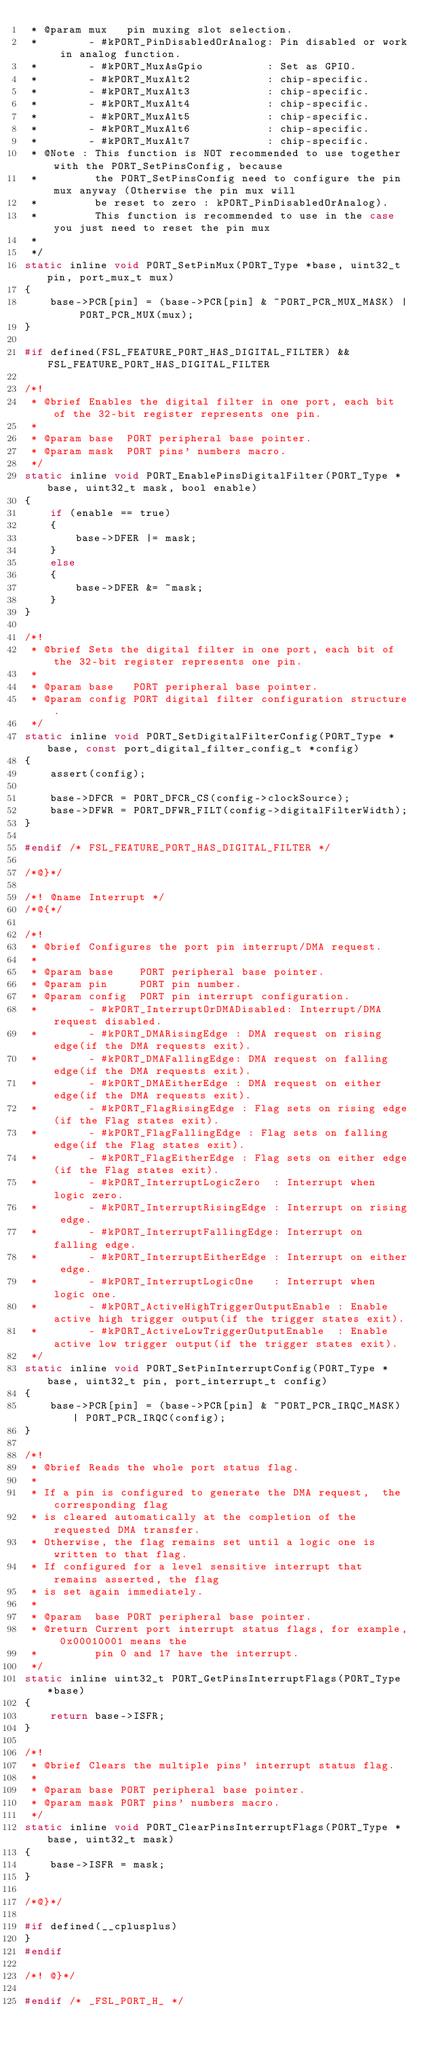<code> <loc_0><loc_0><loc_500><loc_500><_C_> * @param mux   pin muxing slot selection.
 *        - #kPORT_PinDisabledOrAnalog: Pin disabled or work in analog function.
 *        - #kPORT_MuxAsGpio          : Set as GPIO.
 *        - #kPORT_MuxAlt2            : chip-specific.
 *        - #kPORT_MuxAlt3            : chip-specific.
 *        - #kPORT_MuxAlt4            : chip-specific.
 *        - #kPORT_MuxAlt5            : chip-specific.
 *        - #kPORT_MuxAlt6            : chip-specific.
 *        - #kPORT_MuxAlt7            : chip-specific.
 * @Note : This function is NOT recommended to use together with the PORT_SetPinsConfig, because
 *         the PORT_SetPinsConfig need to configure the pin mux anyway (Otherwise the pin mux will
 *         be reset to zero : kPORT_PinDisabledOrAnalog).
 *         This function is recommended to use in the case you just need to reset the pin mux
 *
 */
static inline void PORT_SetPinMux(PORT_Type *base, uint32_t pin, port_mux_t mux)
{
    base->PCR[pin] = (base->PCR[pin] & ~PORT_PCR_MUX_MASK) | PORT_PCR_MUX(mux);
}

#if defined(FSL_FEATURE_PORT_HAS_DIGITAL_FILTER) && FSL_FEATURE_PORT_HAS_DIGITAL_FILTER

/*!
 * @brief Enables the digital filter in one port, each bit of the 32-bit register represents one pin.
 *
 * @param base  PORT peripheral base pointer.
 * @param mask  PORT pins' numbers macro.
 */
static inline void PORT_EnablePinsDigitalFilter(PORT_Type *base, uint32_t mask, bool enable)
{
    if (enable == true)
    {
        base->DFER |= mask;
    }
    else
    {
        base->DFER &= ~mask;
    }
}

/*!
 * @brief Sets the digital filter in one port, each bit of the 32-bit register represents one pin.
 *
 * @param base   PORT peripheral base pointer.
 * @param config PORT digital filter configuration structure.
 */
static inline void PORT_SetDigitalFilterConfig(PORT_Type *base, const port_digital_filter_config_t *config)
{
    assert(config);

    base->DFCR = PORT_DFCR_CS(config->clockSource);
    base->DFWR = PORT_DFWR_FILT(config->digitalFilterWidth);
}

#endif /* FSL_FEATURE_PORT_HAS_DIGITAL_FILTER */

/*@}*/

/*! @name Interrupt */
/*@{*/

/*!
 * @brief Configures the port pin interrupt/DMA request.
 *
 * @param base    PORT peripheral base pointer.
 * @param pin     PORT pin number.
 * @param config  PORT pin interrupt configuration.
 *        - #kPORT_InterruptOrDMADisabled: Interrupt/DMA request disabled.
 *        - #kPORT_DMARisingEdge : DMA request on rising edge(if the DMA requests exit).
 *        - #kPORT_DMAFallingEdge: DMA request on falling edge(if the DMA requests exit).
 *        - #kPORT_DMAEitherEdge : DMA request on either edge(if the DMA requests exit).
 *        - #kPORT_FlagRisingEdge : Flag sets on rising edge(if the Flag states exit).
 *        - #kPORT_FlagFallingEdge : Flag sets on falling edge(if the Flag states exit).
 *        - #kPORT_FlagEitherEdge : Flag sets on either edge(if the Flag states exit).
 *        - #kPORT_InterruptLogicZero  : Interrupt when logic zero.
 *        - #kPORT_InterruptRisingEdge : Interrupt on rising edge.
 *        - #kPORT_InterruptFallingEdge: Interrupt on falling edge.
 *        - #kPORT_InterruptEitherEdge : Interrupt on either edge.
 *        - #kPORT_InterruptLogicOne   : Interrupt when logic one.
 *        - #kPORT_ActiveHighTriggerOutputEnable : Enable active high trigger output(if the trigger states exit).
 *        - #kPORT_ActiveLowTriggerOutputEnable  : Enable active low trigger output(if the trigger states exit).
 */
static inline void PORT_SetPinInterruptConfig(PORT_Type *base, uint32_t pin, port_interrupt_t config)
{
    base->PCR[pin] = (base->PCR[pin] & ~PORT_PCR_IRQC_MASK) | PORT_PCR_IRQC(config);
}

/*!
 * @brief Reads the whole port status flag.
 *
 * If a pin is configured to generate the DMA request,  the corresponding flag
 * is cleared automatically at the completion of the requested DMA transfer.
 * Otherwise, the flag remains set until a logic one is written to that flag.
 * If configured for a level sensitive interrupt that remains asserted, the flag
 * is set again immediately.
 *
 * @param  base PORT peripheral base pointer.
 * @return Current port interrupt status flags, for example, 0x00010001 means the
 *         pin 0 and 17 have the interrupt.
 */
static inline uint32_t PORT_GetPinsInterruptFlags(PORT_Type *base)
{
    return base->ISFR;
}

/*!
 * @brief Clears the multiple pins' interrupt status flag.
 *
 * @param base PORT peripheral base pointer.
 * @param mask PORT pins' numbers macro.
 */
static inline void PORT_ClearPinsInterruptFlags(PORT_Type *base, uint32_t mask)
{
    base->ISFR = mask;
}

/*@}*/

#if defined(__cplusplus)
}
#endif

/*! @}*/

#endif /* _FSL_PORT_H_ */
</code> 